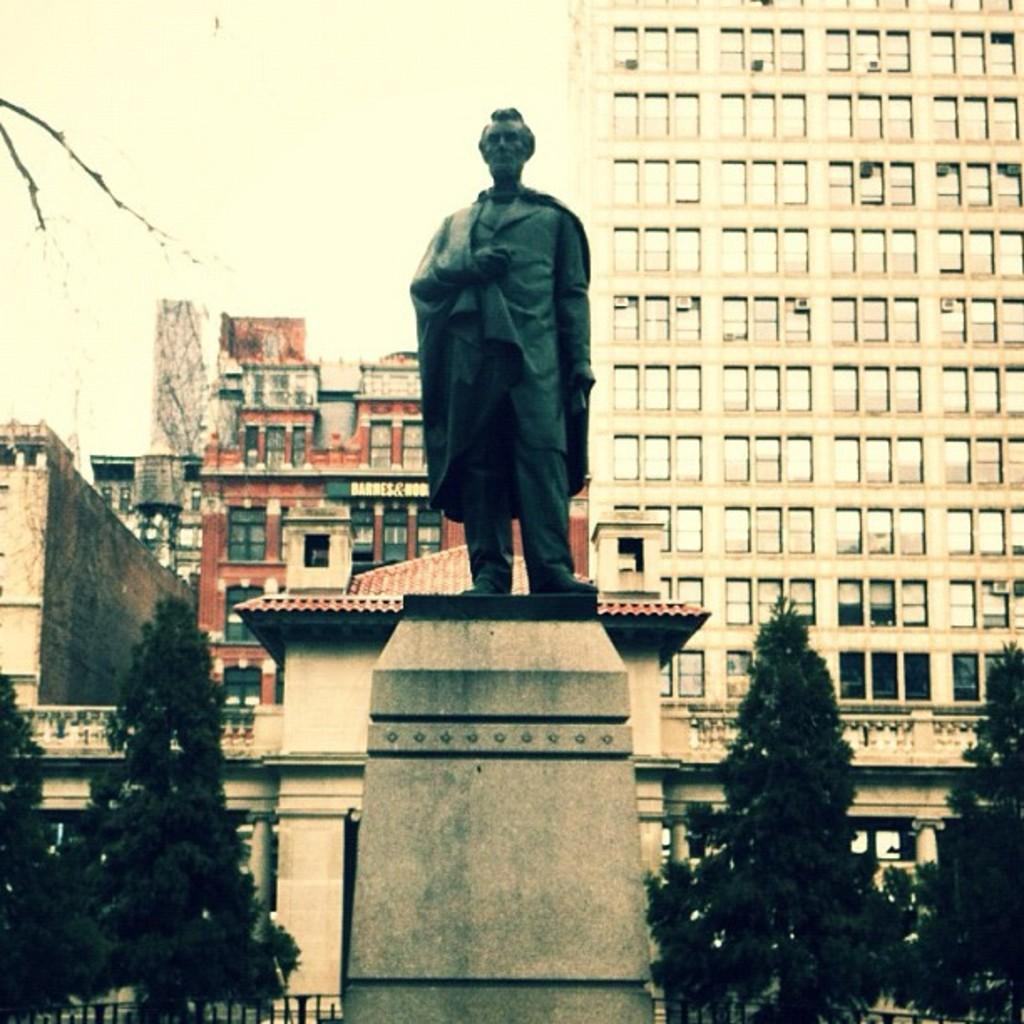Describe this image in one or two sentences. In this picture we can see a statue in the front, in the background there are some buildings, we can see trees at the bottom, there is the sky at the top of the picture, we can also see windows and glasses of these buildings. 